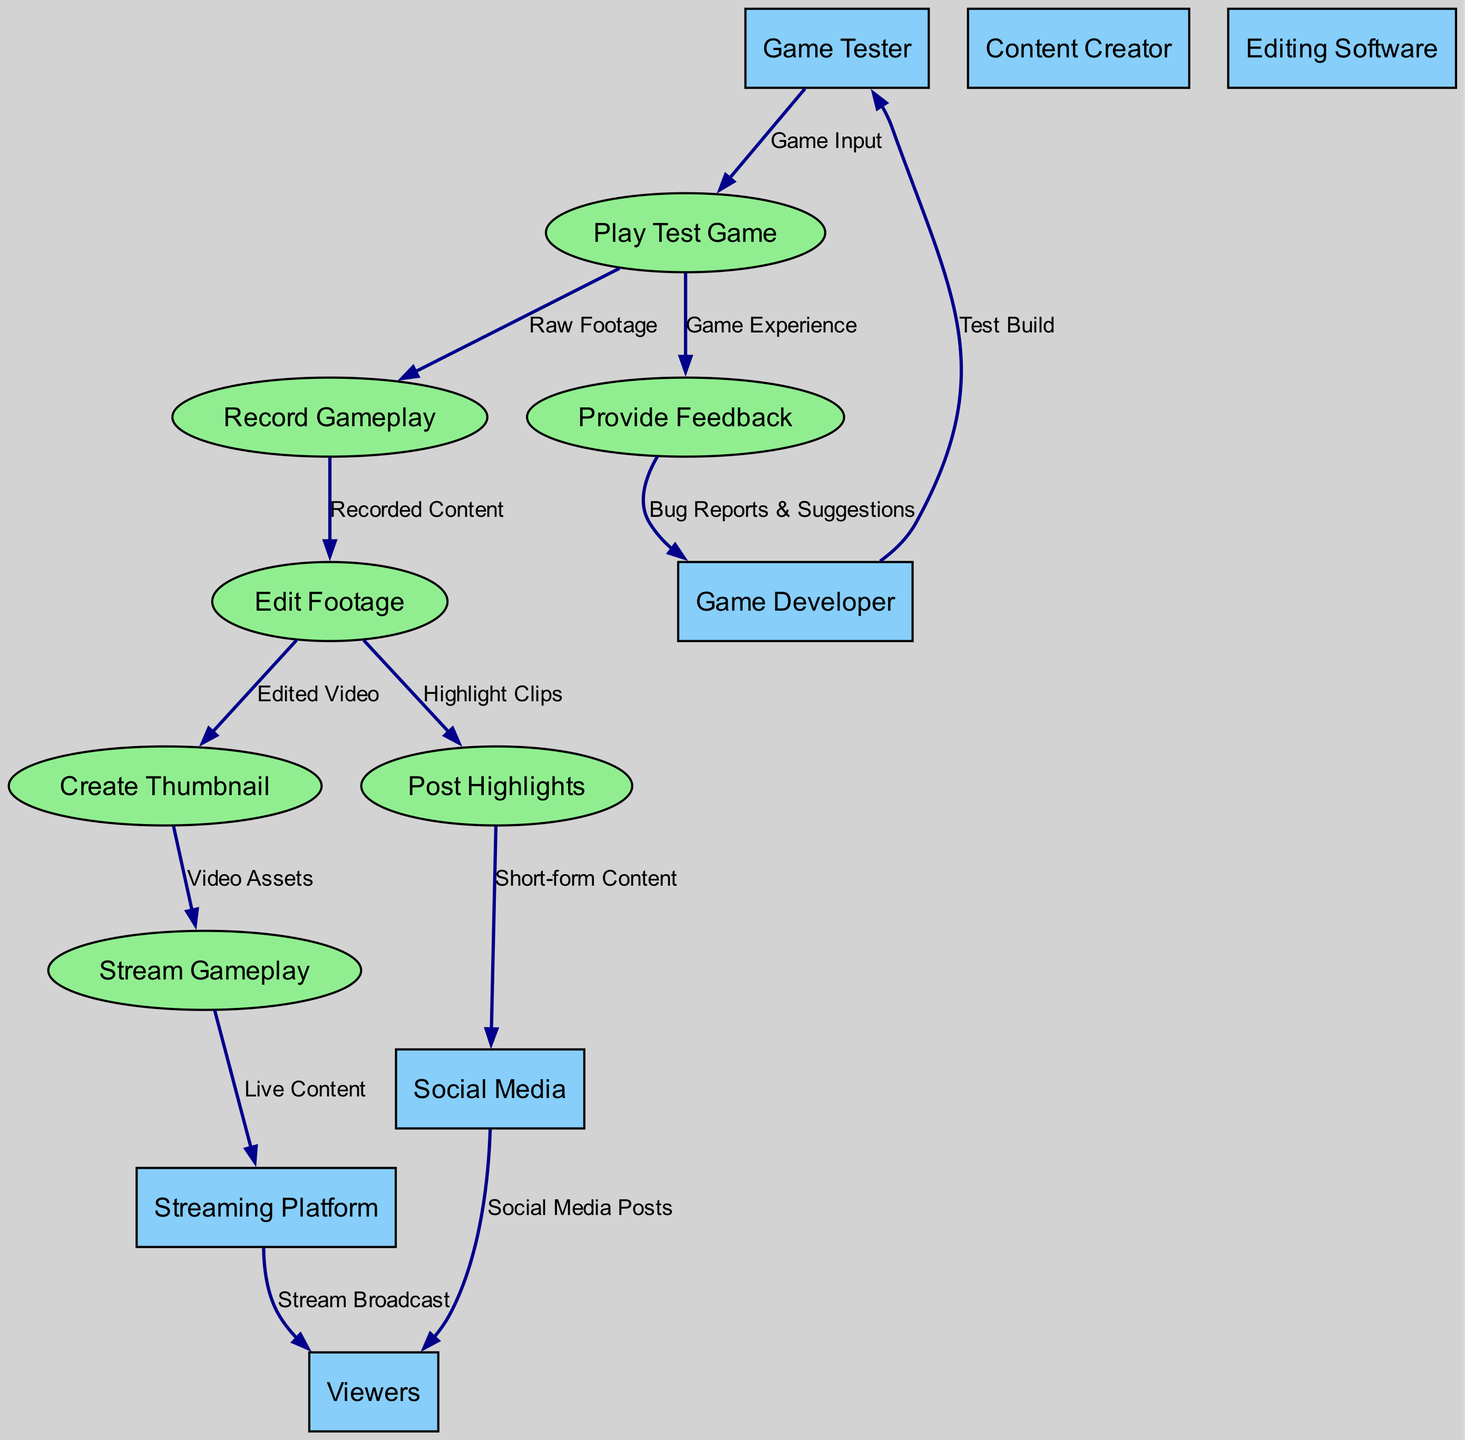What is the first entity in the workflow? The first entity in the workflow, as indicated by the data flows, is the Game Developer which provides the test build to the Game Tester.
Answer: Game Developer How many processes are there in the diagram? The diagram lists a total of seven distinct processes related to content creation, from playing and testing the game to editing and publishing.
Answer: Seven What does the Game Tester provide to the Game Developer? The Game Tester provides Bug Reports & Suggestions to the Game Developer, as indicated by the flow labeled from Provide Feedback to Game Developer.
Answer: Bug Reports & Suggestions Which process follows "Edit Footage"? After the "Edit Footage" process, the next process is "Create Thumbnail," as shown in the data flows indicating the sequence of activities.
Answer: Create Thumbnail What kind of content is streamed to the Streaming Platform? The content streamed to the Streaming Platform is labeled as Live Content, indicating that it is real-time streaming activity derived from the gameplay process.
Answer: Live Content How does the content reach the Viewers from the Streaming Platform? The Streaming Platform broadcasts the stream to Viewers, as shown by the data flow from Streaming Platform to Viewers labeled "Stream Broadcast."
Answer: Stream Broadcast What is the relationship between "Post Highlights" and "Social Media"? The relationship is that "Post Highlights" generates Short-form Content, which is then shared on Social Media, as indicated by the flow from Post Highlights to Social Media.
Answer: Short-form Content Which process is initiated by "Record Gameplay"? The process that is initiated by "Record Gameplay" is "Edit Footage," as shown by the data flow where recorded content is then edited for further use.
Answer: Edit Footage What is the role of the Content Creator in the workflow? In the context of this diagram, the Content Creator's role is implied in the processes surrounding the creation and dissemination of video content but is not directly labeled in the data flows.
Answer: Implied role 